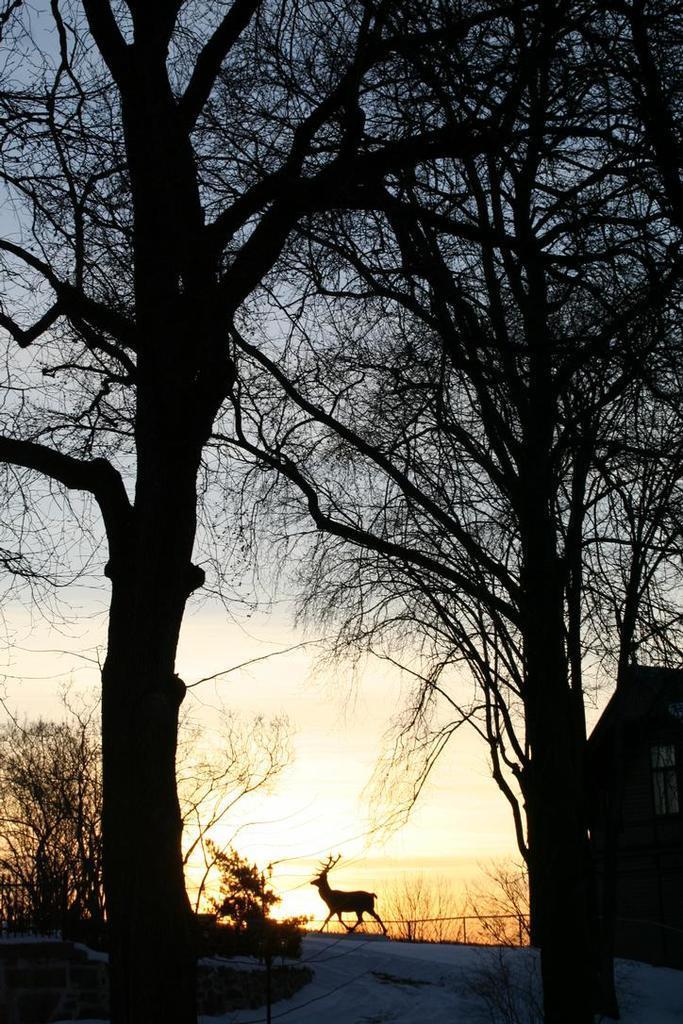In one or two sentences, can you explain what this image depicts? In the foreground of the picture there are trees, plants, house, road, railing and an antelope. In the background it is sky. 